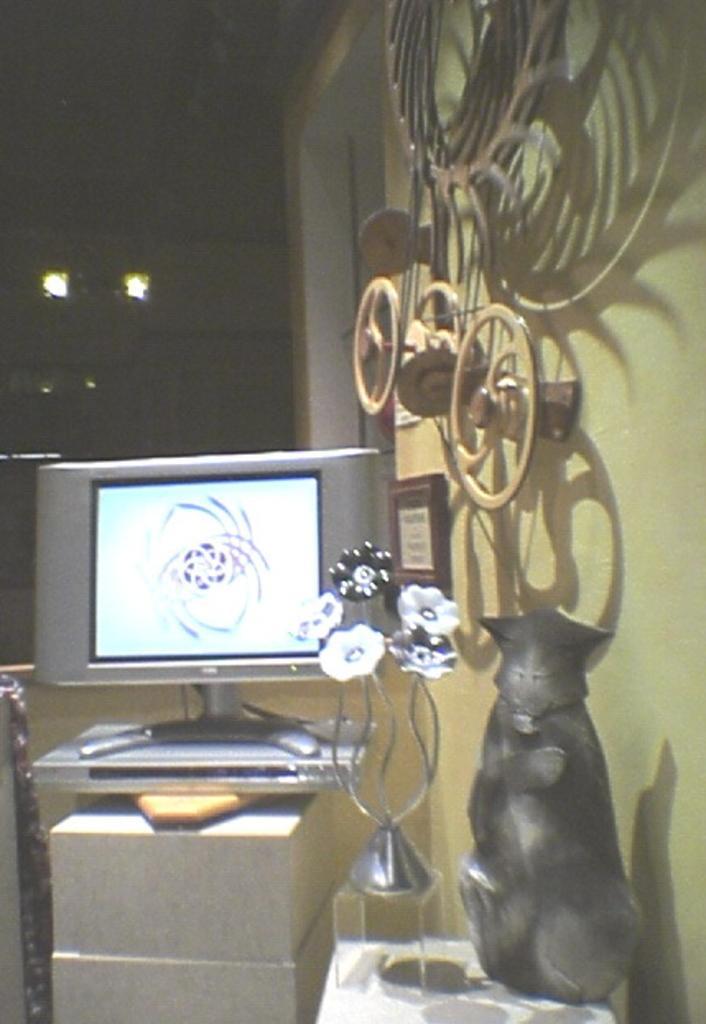Describe this image in one or two sentences. On the right side there is a wall. On the wall there is a photo frame and some decorative item. Near to that there is a table. On that there is a toy and a decorative item. Also there is a television and an electronic device on a block. In the back there are lights. 